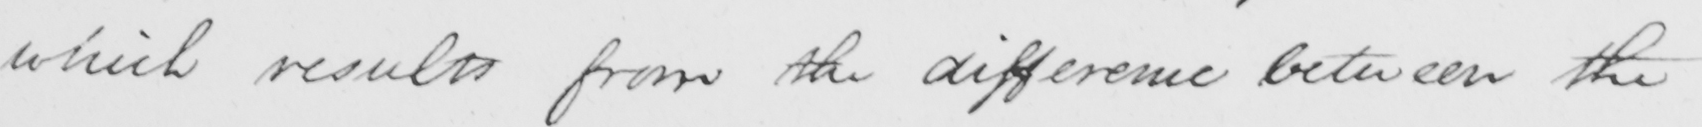Transcribe the text shown in this historical manuscript line. which results from the difference between the 